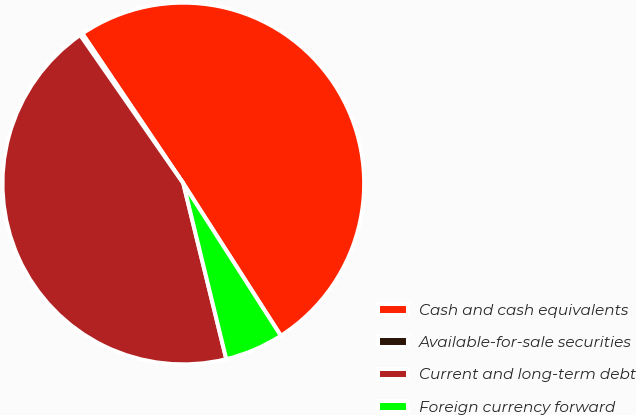Convert chart to OTSL. <chart><loc_0><loc_0><loc_500><loc_500><pie_chart><fcel>Cash and cash equivalents<fcel>Available-for-sale securities<fcel>Current and long-term debt<fcel>Foreign currency forward<nl><fcel>50.36%<fcel>0.23%<fcel>44.15%<fcel>5.25%<nl></chart> 